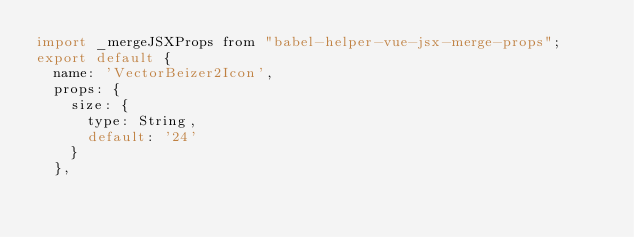Convert code to text. <code><loc_0><loc_0><loc_500><loc_500><_JavaScript_>import _mergeJSXProps from "babel-helper-vue-jsx-merge-props";
export default {
  name: 'VectorBeizer2Icon',
  props: {
    size: {
      type: String,
      default: '24'
    }
  },</code> 